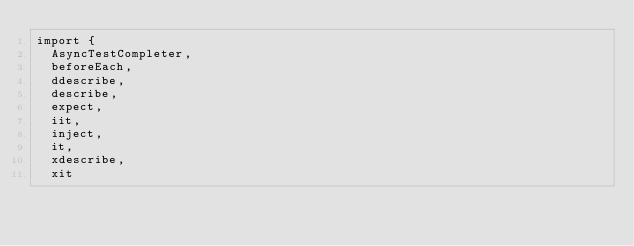Convert code to text. <code><loc_0><loc_0><loc_500><loc_500><_TypeScript_>import {
  AsyncTestCompleter,
  beforeEach,
  ddescribe,
  describe,
  expect,
  iit,
  inject,
  it,
  xdescribe,
  xit</code> 